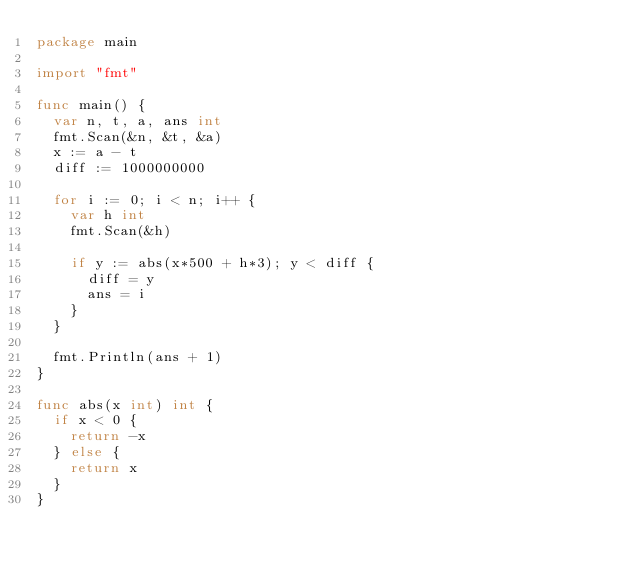<code> <loc_0><loc_0><loc_500><loc_500><_Go_>package main

import "fmt"

func main() {
	var n, t, a, ans int
	fmt.Scan(&n, &t, &a)
	x := a - t
	diff := 1000000000

	for i := 0; i < n; i++ {
		var h int
		fmt.Scan(&h)

		if y := abs(x*500 + h*3); y < diff {
			diff = y
			ans = i
		}
	}

	fmt.Println(ans + 1)
}

func abs(x int) int {
	if x < 0 {
		return -x
	} else {
		return x
	}
}
</code> 